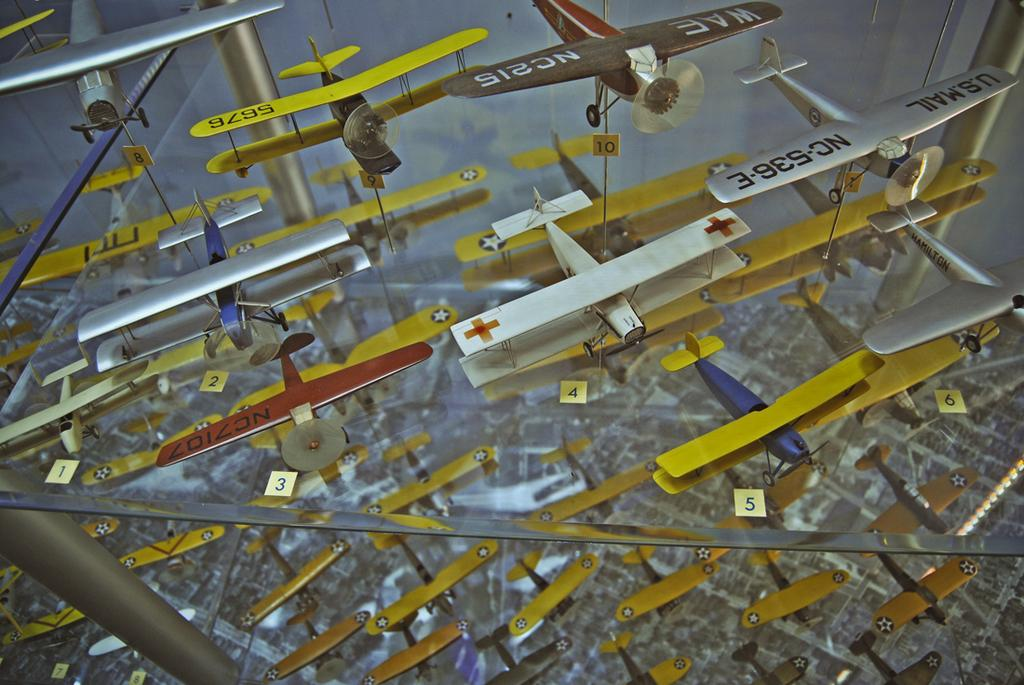What is the main subject of the image? The main subject of the image is many airplanes. Where are the airplanes located in the image? The airplanes are on a glass table. What type of bubble can be seen floating near the airplanes in the image? There is no bubble present in the image; it only features airplanes on a glass table. What kind of medical advice can be obtained from the doctor in the image? There is no doctor present in the image; it only features airplanes on a glass table. 